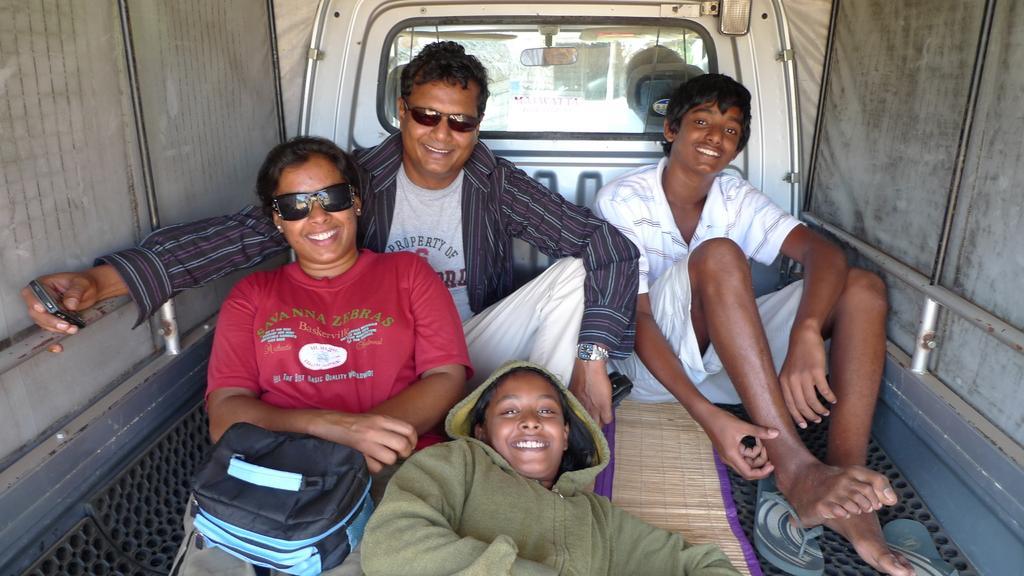Please provide a concise description of this image. This picture is taken inside a vehicle, there are some people sitting and some are lying, at the left side there is a woman, she is wearing black color specs. 